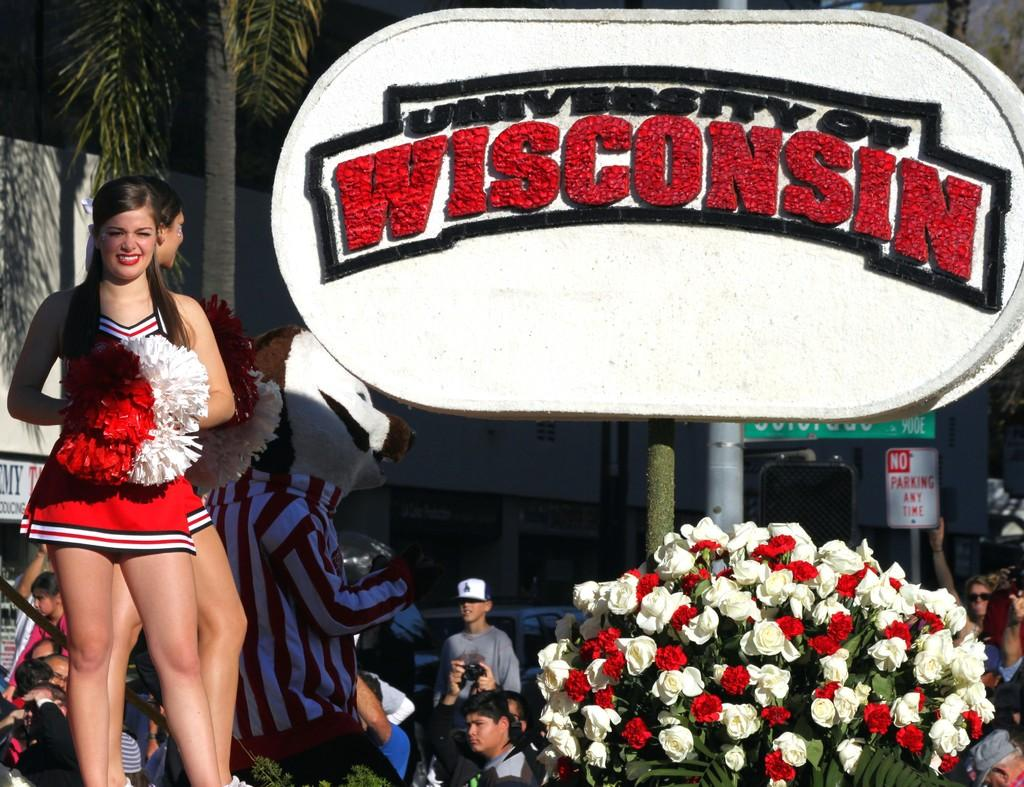Provide a one-sentence caption for the provided image. A cheerleader stand on the stage representing University of Wisconsin. 